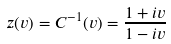Convert formula to latex. <formula><loc_0><loc_0><loc_500><loc_500>z ( v ) = C ^ { - 1 } ( v ) = \frac { 1 + i v } { 1 - i v }</formula> 